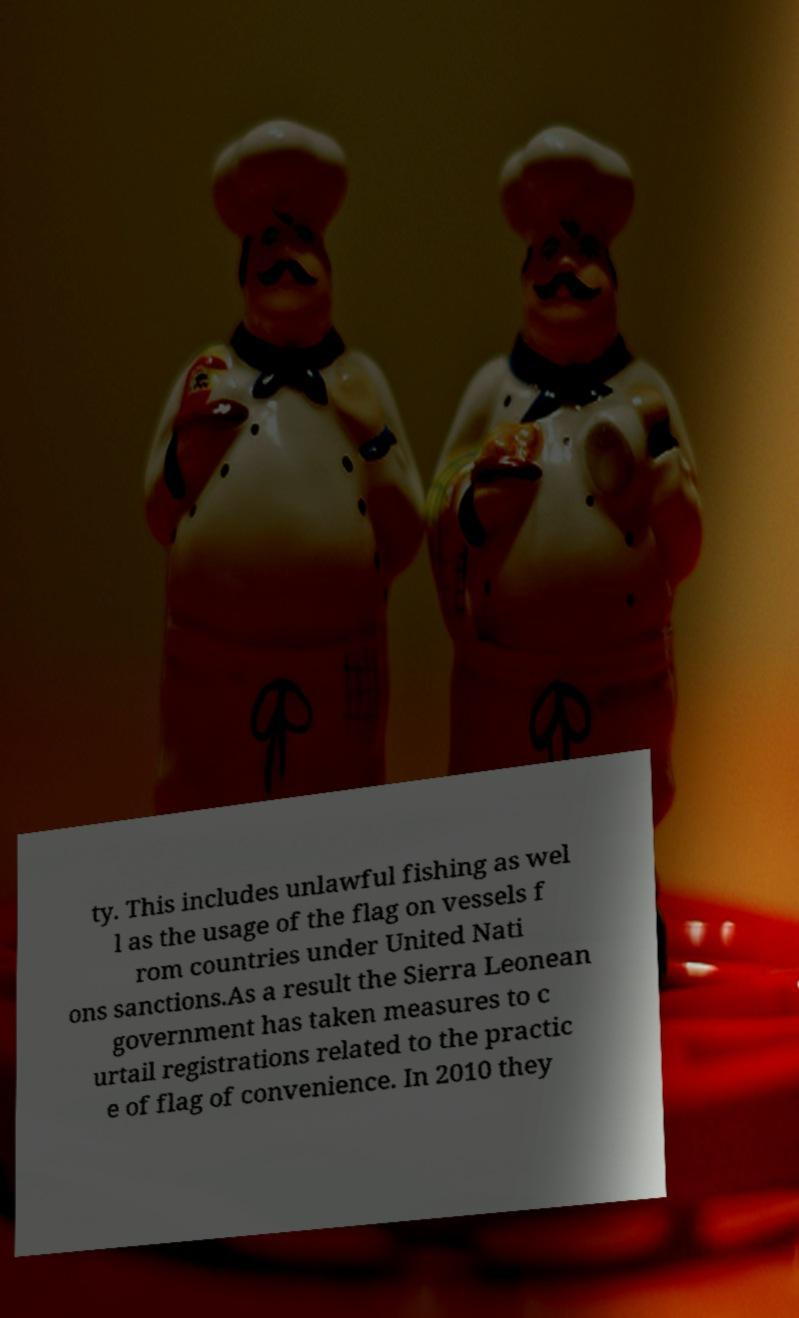I need the written content from this picture converted into text. Can you do that? ty. This includes unlawful fishing as wel l as the usage of the flag on vessels f rom countries under United Nati ons sanctions.As a result the Sierra Leonean government has taken measures to c urtail registrations related to the practic e of flag of convenience. In 2010 they 